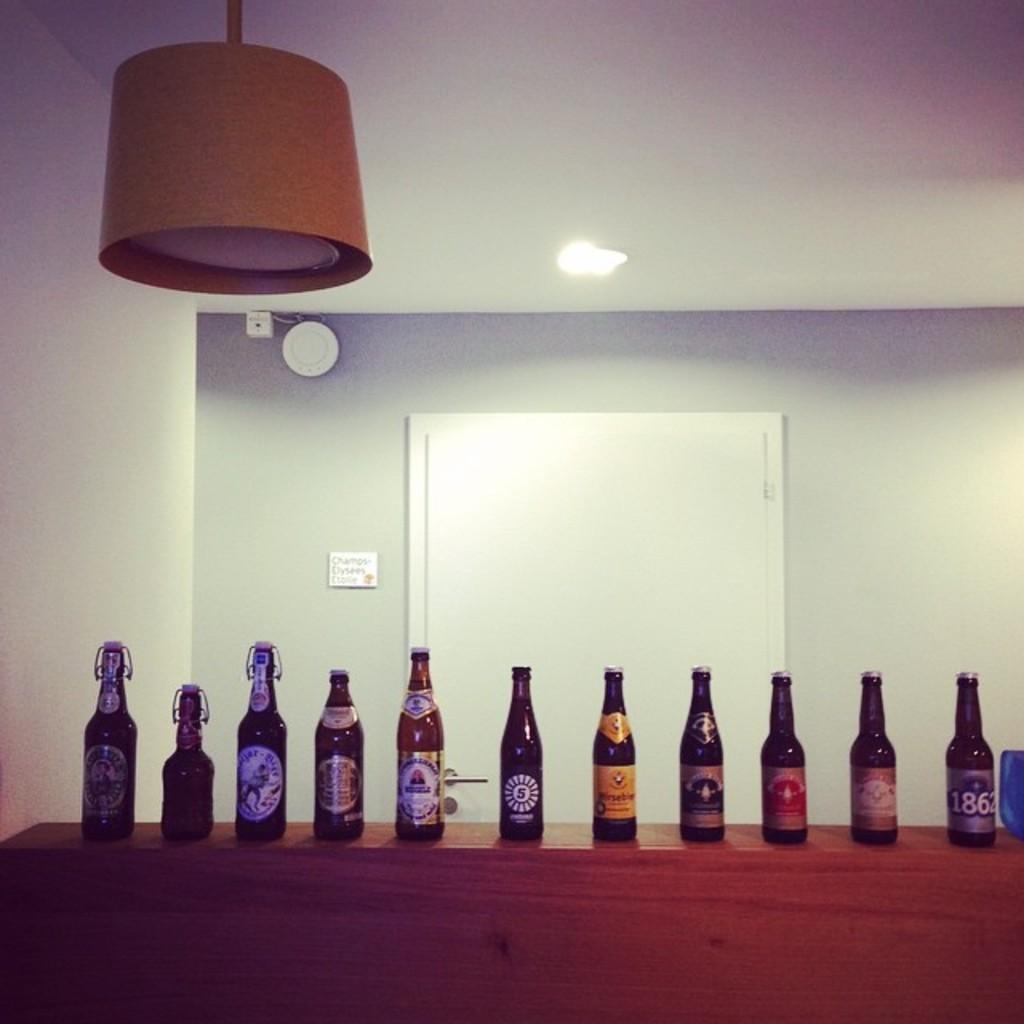What´s the year on the last beer of the right?
Your answer should be very brief. 1862. 